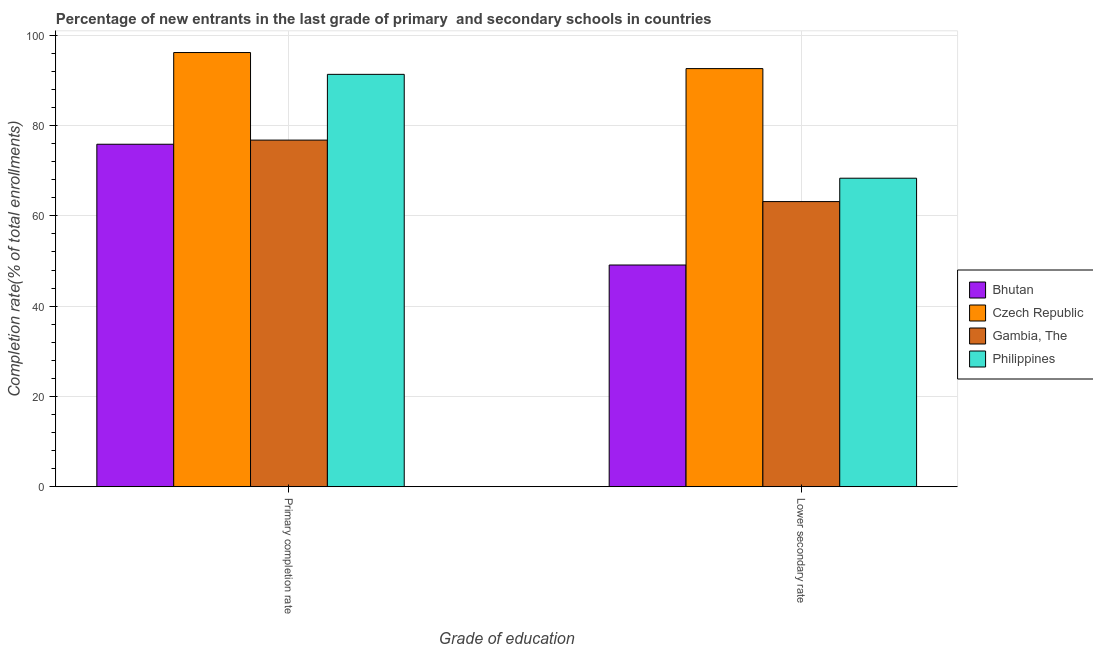How many bars are there on the 2nd tick from the right?
Make the answer very short. 4. What is the label of the 1st group of bars from the left?
Ensure brevity in your answer.  Primary completion rate. What is the completion rate in secondary schools in Czech Republic?
Your answer should be very brief. 92.61. Across all countries, what is the maximum completion rate in secondary schools?
Your answer should be very brief. 92.61. Across all countries, what is the minimum completion rate in secondary schools?
Offer a very short reply. 49.11. In which country was the completion rate in primary schools maximum?
Provide a succinct answer. Czech Republic. In which country was the completion rate in primary schools minimum?
Provide a succinct answer. Bhutan. What is the total completion rate in primary schools in the graph?
Offer a terse response. 340.15. What is the difference between the completion rate in secondary schools in Czech Republic and that in Philippines?
Your answer should be compact. 24.28. What is the difference between the completion rate in primary schools in Bhutan and the completion rate in secondary schools in Czech Republic?
Make the answer very short. -16.75. What is the average completion rate in secondary schools per country?
Offer a terse response. 68.3. What is the difference between the completion rate in primary schools and completion rate in secondary schools in Bhutan?
Provide a short and direct response. 26.75. What is the ratio of the completion rate in primary schools in Bhutan to that in Gambia, The?
Make the answer very short. 0.99. What does the 3rd bar from the left in Primary completion rate represents?
Make the answer very short. Gambia, The. What does the 3rd bar from the right in Primary completion rate represents?
Your answer should be very brief. Czech Republic. How many bars are there?
Ensure brevity in your answer.  8. Are all the bars in the graph horizontal?
Provide a succinct answer. No. How many countries are there in the graph?
Provide a succinct answer. 4. What is the difference between two consecutive major ticks on the Y-axis?
Offer a very short reply. 20. Are the values on the major ticks of Y-axis written in scientific E-notation?
Your answer should be very brief. No. Does the graph contain grids?
Offer a terse response. Yes. Where does the legend appear in the graph?
Your answer should be compact. Center right. What is the title of the graph?
Offer a very short reply. Percentage of new entrants in the last grade of primary  and secondary schools in countries. What is the label or title of the X-axis?
Your answer should be compact. Grade of education. What is the label or title of the Y-axis?
Provide a succinct answer. Completion rate(% of total enrollments). What is the Completion rate(% of total enrollments) of Bhutan in Primary completion rate?
Offer a very short reply. 75.86. What is the Completion rate(% of total enrollments) of Czech Republic in Primary completion rate?
Offer a very short reply. 96.17. What is the Completion rate(% of total enrollments) in Gambia, The in Primary completion rate?
Your answer should be very brief. 76.78. What is the Completion rate(% of total enrollments) of Philippines in Primary completion rate?
Offer a terse response. 91.34. What is the Completion rate(% of total enrollments) in Bhutan in Lower secondary rate?
Provide a short and direct response. 49.11. What is the Completion rate(% of total enrollments) of Czech Republic in Lower secondary rate?
Make the answer very short. 92.61. What is the Completion rate(% of total enrollments) of Gambia, The in Lower secondary rate?
Your answer should be compact. 63.16. What is the Completion rate(% of total enrollments) of Philippines in Lower secondary rate?
Keep it short and to the point. 68.34. Across all Grade of education, what is the maximum Completion rate(% of total enrollments) in Bhutan?
Give a very brief answer. 75.86. Across all Grade of education, what is the maximum Completion rate(% of total enrollments) in Czech Republic?
Your answer should be very brief. 96.17. Across all Grade of education, what is the maximum Completion rate(% of total enrollments) of Gambia, The?
Make the answer very short. 76.78. Across all Grade of education, what is the maximum Completion rate(% of total enrollments) in Philippines?
Make the answer very short. 91.34. Across all Grade of education, what is the minimum Completion rate(% of total enrollments) in Bhutan?
Ensure brevity in your answer.  49.11. Across all Grade of education, what is the minimum Completion rate(% of total enrollments) in Czech Republic?
Ensure brevity in your answer.  92.61. Across all Grade of education, what is the minimum Completion rate(% of total enrollments) of Gambia, The?
Make the answer very short. 63.16. Across all Grade of education, what is the minimum Completion rate(% of total enrollments) in Philippines?
Ensure brevity in your answer.  68.34. What is the total Completion rate(% of total enrollments) in Bhutan in the graph?
Keep it short and to the point. 124.97. What is the total Completion rate(% of total enrollments) in Czech Republic in the graph?
Your answer should be very brief. 188.79. What is the total Completion rate(% of total enrollments) in Gambia, The in the graph?
Offer a very short reply. 139.93. What is the total Completion rate(% of total enrollments) in Philippines in the graph?
Your answer should be compact. 159.68. What is the difference between the Completion rate(% of total enrollments) in Bhutan in Primary completion rate and that in Lower secondary rate?
Make the answer very short. 26.75. What is the difference between the Completion rate(% of total enrollments) in Czech Republic in Primary completion rate and that in Lower secondary rate?
Provide a succinct answer. 3.56. What is the difference between the Completion rate(% of total enrollments) in Gambia, The in Primary completion rate and that in Lower secondary rate?
Your answer should be compact. 13.62. What is the difference between the Completion rate(% of total enrollments) in Philippines in Primary completion rate and that in Lower secondary rate?
Your answer should be compact. 23.01. What is the difference between the Completion rate(% of total enrollments) of Bhutan in Primary completion rate and the Completion rate(% of total enrollments) of Czech Republic in Lower secondary rate?
Provide a short and direct response. -16.75. What is the difference between the Completion rate(% of total enrollments) in Bhutan in Primary completion rate and the Completion rate(% of total enrollments) in Gambia, The in Lower secondary rate?
Provide a short and direct response. 12.7. What is the difference between the Completion rate(% of total enrollments) in Bhutan in Primary completion rate and the Completion rate(% of total enrollments) in Philippines in Lower secondary rate?
Your response must be concise. 7.53. What is the difference between the Completion rate(% of total enrollments) in Czech Republic in Primary completion rate and the Completion rate(% of total enrollments) in Gambia, The in Lower secondary rate?
Offer a very short reply. 33.02. What is the difference between the Completion rate(% of total enrollments) in Czech Republic in Primary completion rate and the Completion rate(% of total enrollments) in Philippines in Lower secondary rate?
Make the answer very short. 27.84. What is the difference between the Completion rate(% of total enrollments) of Gambia, The in Primary completion rate and the Completion rate(% of total enrollments) of Philippines in Lower secondary rate?
Your answer should be compact. 8.44. What is the average Completion rate(% of total enrollments) of Bhutan per Grade of education?
Provide a short and direct response. 62.49. What is the average Completion rate(% of total enrollments) in Czech Republic per Grade of education?
Make the answer very short. 94.39. What is the average Completion rate(% of total enrollments) in Gambia, The per Grade of education?
Ensure brevity in your answer.  69.97. What is the average Completion rate(% of total enrollments) in Philippines per Grade of education?
Your answer should be compact. 79.84. What is the difference between the Completion rate(% of total enrollments) in Bhutan and Completion rate(% of total enrollments) in Czech Republic in Primary completion rate?
Offer a terse response. -20.31. What is the difference between the Completion rate(% of total enrollments) in Bhutan and Completion rate(% of total enrollments) in Gambia, The in Primary completion rate?
Make the answer very short. -0.92. What is the difference between the Completion rate(% of total enrollments) in Bhutan and Completion rate(% of total enrollments) in Philippines in Primary completion rate?
Provide a succinct answer. -15.48. What is the difference between the Completion rate(% of total enrollments) in Czech Republic and Completion rate(% of total enrollments) in Gambia, The in Primary completion rate?
Your answer should be compact. 19.4. What is the difference between the Completion rate(% of total enrollments) in Czech Republic and Completion rate(% of total enrollments) in Philippines in Primary completion rate?
Keep it short and to the point. 4.83. What is the difference between the Completion rate(% of total enrollments) of Gambia, The and Completion rate(% of total enrollments) of Philippines in Primary completion rate?
Provide a short and direct response. -14.57. What is the difference between the Completion rate(% of total enrollments) in Bhutan and Completion rate(% of total enrollments) in Czech Republic in Lower secondary rate?
Offer a terse response. -43.5. What is the difference between the Completion rate(% of total enrollments) of Bhutan and Completion rate(% of total enrollments) of Gambia, The in Lower secondary rate?
Your answer should be very brief. -14.05. What is the difference between the Completion rate(% of total enrollments) of Bhutan and Completion rate(% of total enrollments) of Philippines in Lower secondary rate?
Offer a very short reply. -19.22. What is the difference between the Completion rate(% of total enrollments) of Czech Republic and Completion rate(% of total enrollments) of Gambia, The in Lower secondary rate?
Your answer should be compact. 29.46. What is the difference between the Completion rate(% of total enrollments) in Czech Republic and Completion rate(% of total enrollments) in Philippines in Lower secondary rate?
Offer a terse response. 24.28. What is the difference between the Completion rate(% of total enrollments) in Gambia, The and Completion rate(% of total enrollments) in Philippines in Lower secondary rate?
Give a very brief answer. -5.18. What is the ratio of the Completion rate(% of total enrollments) of Bhutan in Primary completion rate to that in Lower secondary rate?
Your response must be concise. 1.54. What is the ratio of the Completion rate(% of total enrollments) of Czech Republic in Primary completion rate to that in Lower secondary rate?
Ensure brevity in your answer.  1.04. What is the ratio of the Completion rate(% of total enrollments) of Gambia, The in Primary completion rate to that in Lower secondary rate?
Your answer should be very brief. 1.22. What is the ratio of the Completion rate(% of total enrollments) in Philippines in Primary completion rate to that in Lower secondary rate?
Offer a very short reply. 1.34. What is the difference between the highest and the second highest Completion rate(% of total enrollments) in Bhutan?
Provide a succinct answer. 26.75. What is the difference between the highest and the second highest Completion rate(% of total enrollments) in Czech Republic?
Offer a terse response. 3.56. What is the difference between the highest and the second highest Completion rate(% of total enrollments) in Gambia, The?
Give a very brief answer. 13.62. What is the difference between the highest and the second highest Completion rate(% of total enrollments) of Philippines?
Offer a very short reply. 23.01. What is the difference between the highest and the lowest Completion rate(% of total enrollments) of Bhutan?
Provide a short and direct response. 26.75. What is the difference between the highest and the lowest Completion rate(% of total enrollments) of Czech Republic?
Offer a terse response. 3.56. What is the difference between the highest and the lowest Completion rate(% of total enrollments) of Gambia, The?
Offer a very short reply. 13.62. What is the difference between the highest and the lowest Completion rate(% of total enrollments) of Philippines?
Your response must be concise. 23.01. 